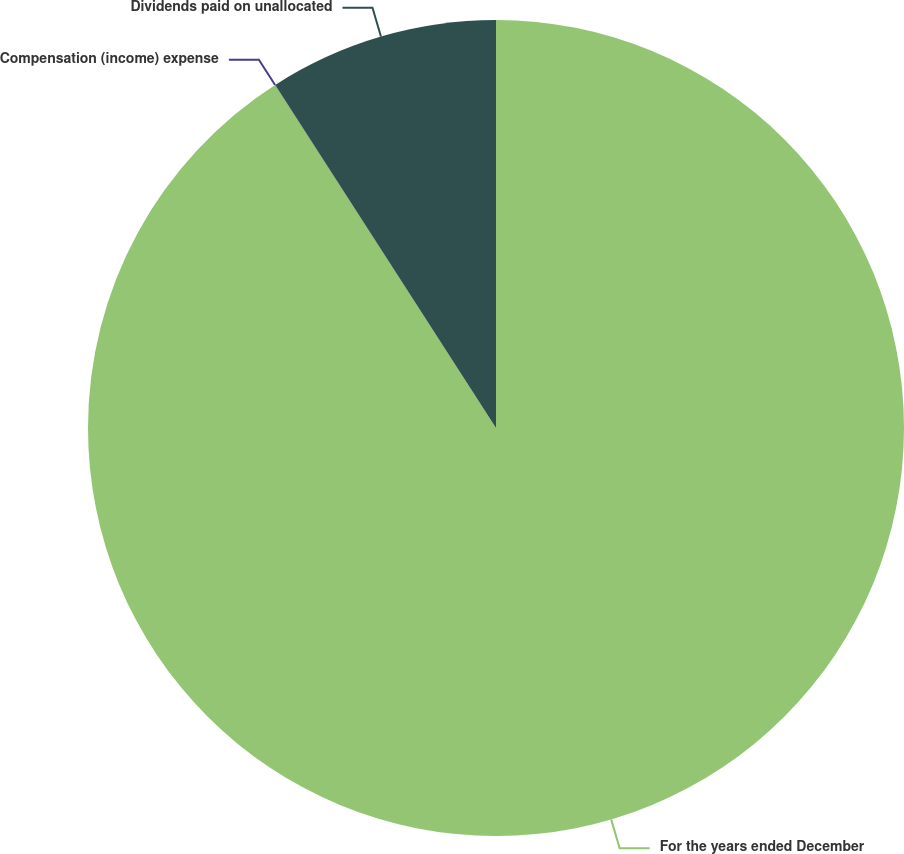Convert chart. <chart><loc_0><loc_0><loc_500><loc_500><pie_chart><fcel>For the years ended December<fcel>Compensation (income) expense<fcel>Dividends paid on unallocated<nl><fcel>90.89%<fcel>0.01%<fcel>9.1%<nl></chart> 